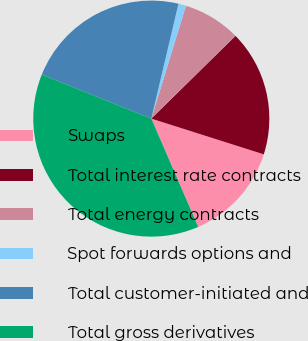Convert chart to OTSL. <chart><loc_0><loc_0><loc_500><loc_500><pie_chart><fcel>Swaps<fcel>Total interest rate contracts<fcel>Total energy contracts<fcel>Spot forwards options and<fcel>Total customer-initiated and<fcel>Total gross derivatives<nl><fcel>13.6%<fcel>17.26%<fcel>7.89%<fcel>1.05%<fcel>22.62%<fcel>37.58%<nl></chart> 